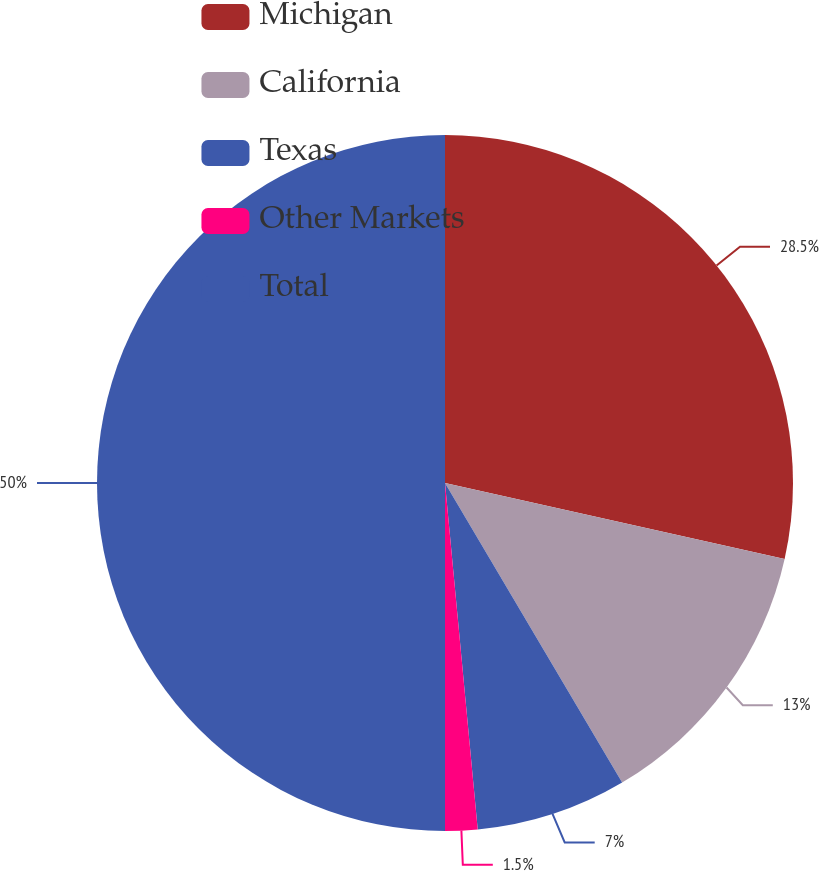Convert chart. <chart><loc_0><loc_0><loc_500><loc_500><pie_chart><fcel>Michigan<fcel>California<fcel>Texas<fcel>Other Markets<fcel>Total<nl><fcel>28.5%<fcel>13.0%<fcel>7.0%<fcel>1.5%<fcel>50.0%<nl></chart> 